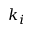Convert formula to latex. <formula><loc_0><loc_0><loc_500><loc_500>k _ { i }</formula> 